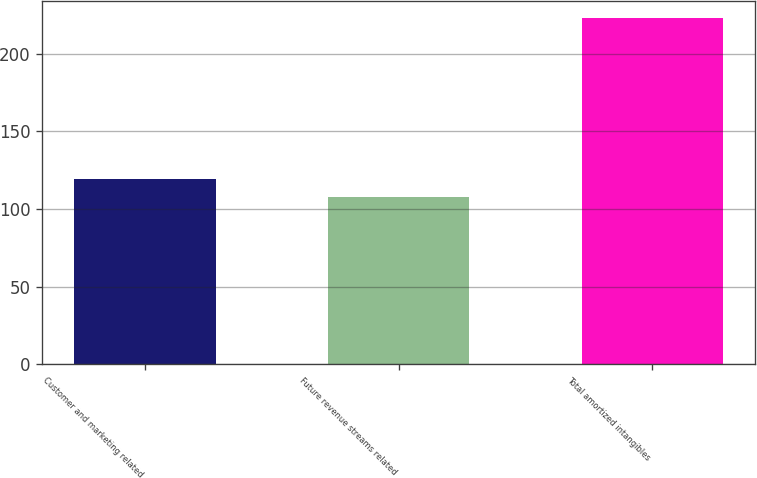Convert chart to OTSL. <chart><loc_0><loc_0><loc_500><loc_500><bar_chart><fcel>Customer and marketing related<fcel>Future revenue streams related<fcel>Total amortized intangibles<nl><fcel>119.5<fcel>108<fcel>223<nl></chart> 